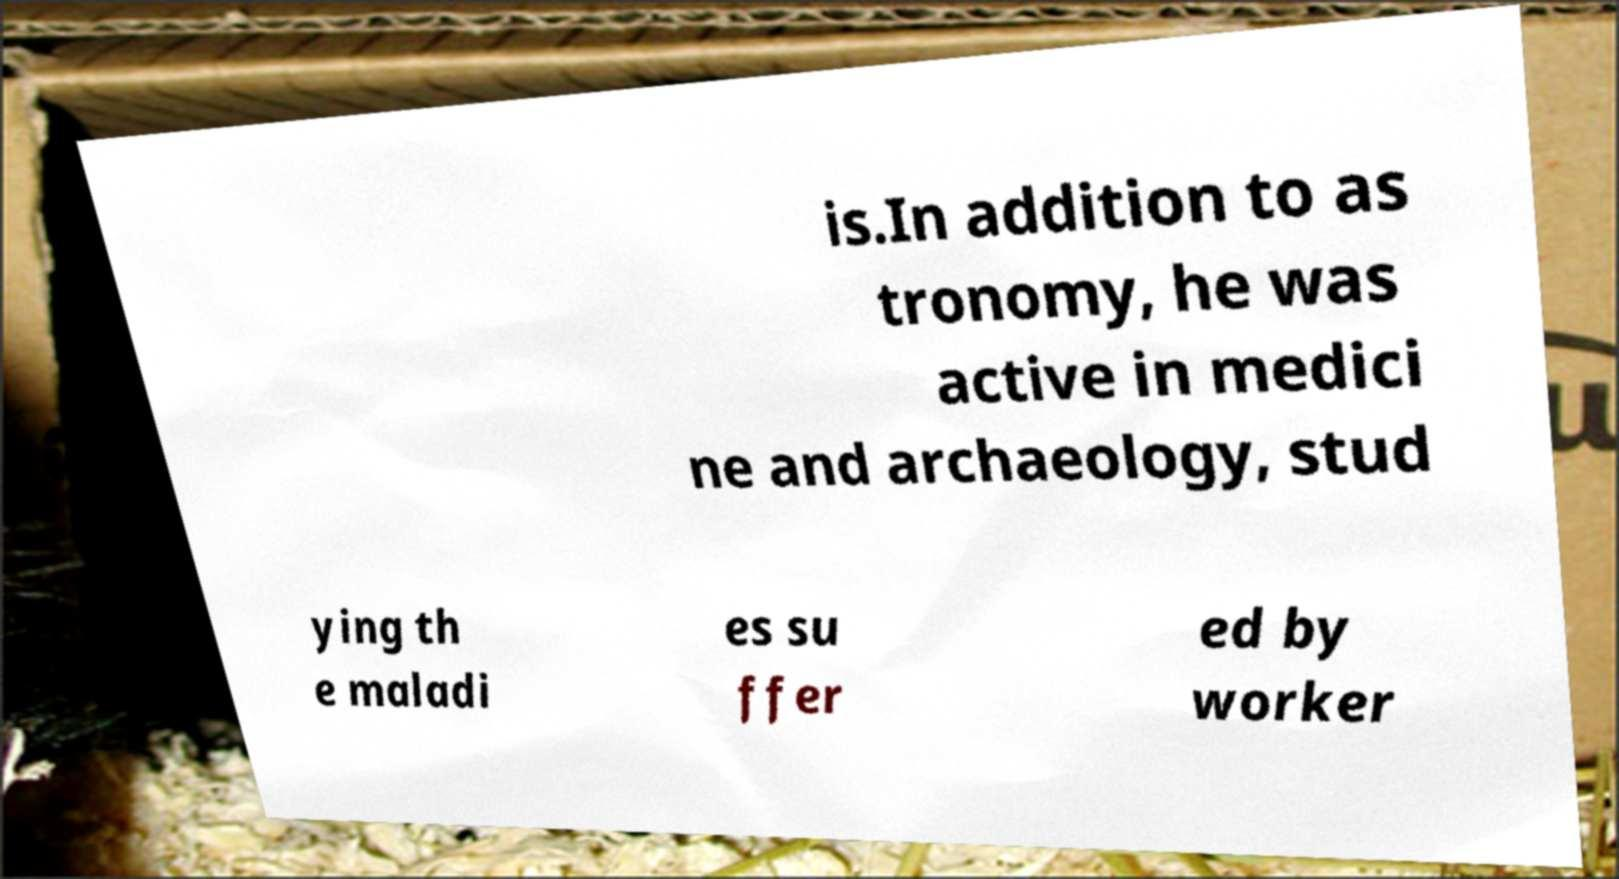Could you extract and type out the text from this image? is.In addition to as tronomy, he was active in medici ne and archaeology, stud ying th e maladi es su ffer ed by worker 